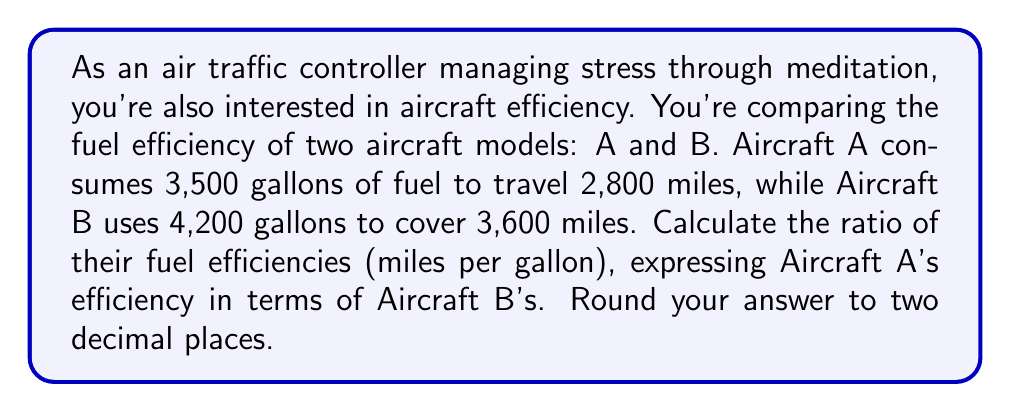Teach me how to tackle this problem. Let's approach this step-by-step:

1) First, calculate the fuel efficiency (miles per gallon) for each aircraft:

   For Aircraft A: 
   $$ \text{Efficiency}_A = \frac{2,800 \text{ miles}}{3,500 \text{ gallons}} = 0.8 \text{ miles/gallon} $$

   For Aircraft B:
   $$ \text{Efficiency}_B = \frac{3,600 \text{ miles}}{4,200 \text{ gallons}} \approx 0.8571 \text{ miles/gallon} $$

2) Now, to express Aircraft A's efficiency in terms of Aircraft B's, we need to find the ratio:

   $$ \text{Ratio} = \frac{\text{Efficiency}_A}{\text{Efficiency}_B} = \frac{0.8}{0.8571} $$

3) Perform the division:

   $$ \frac{0.8}{0.8571} \approx 0.9333 $$

4) Rounding to two decimal places:

   $$ 0.9333 \approx 0.93 $$

Thus, Aircraft A's fuel efficiency is approximately 0.93 times that of Aircraft B.
Answer: 0.93 